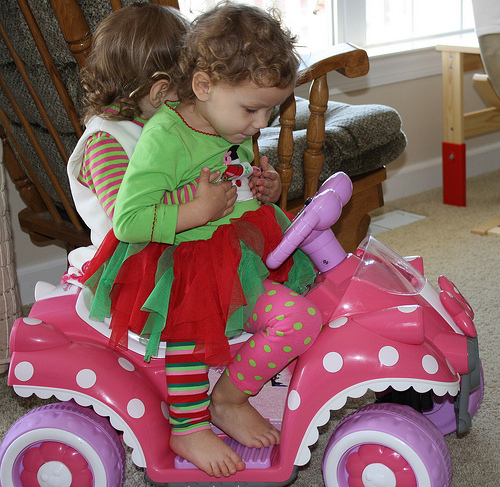<image>
Is the kid one on the kid two? Yes. Looking at the image, I can see the kid one is positioned on top of the kid two, with the kid two providing support. Where is the child in relation to the car? Is it on the car? Yes. Looking at the image, I can see the child is positioned on top of the car, with the car providing support. 